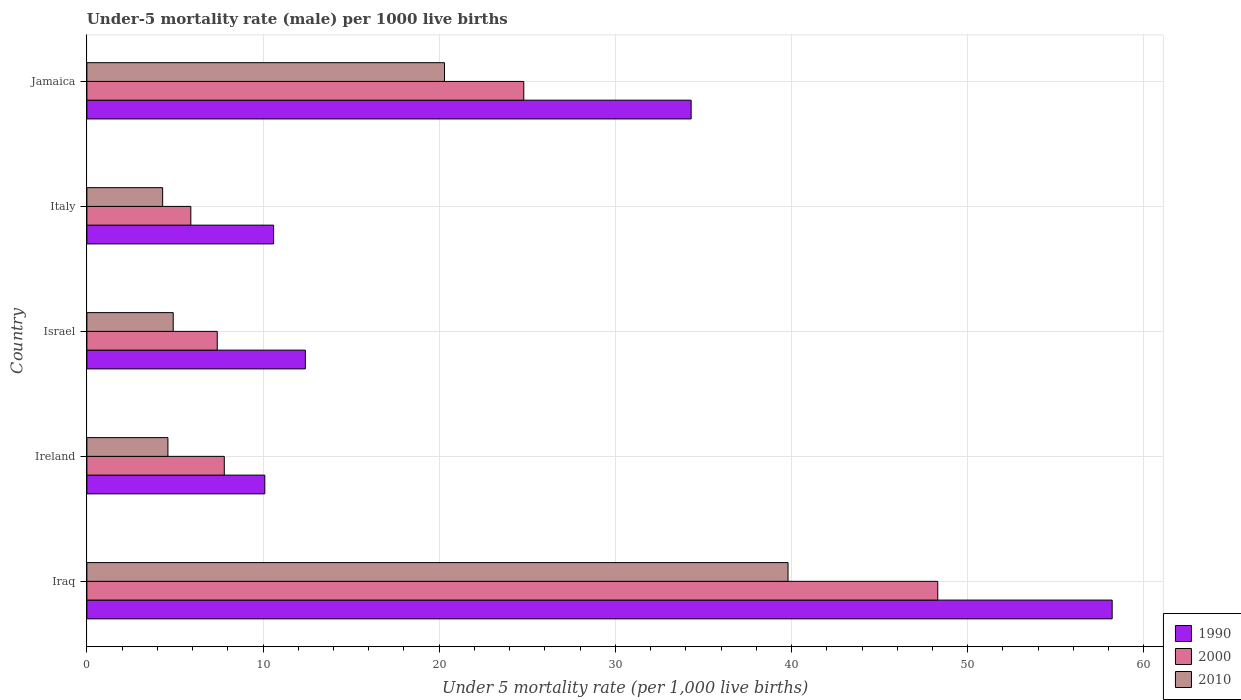How many groups of bars are there?
Offer a very short reply. 5. Are the number of bars on each tick of the Y-axis equal?
Provide a short and direct response. Yes. In how many cases, is the number of bars for a given country not equal to the number of legend labels?
Your answer should be very brief. 0. What is the under-five mortality rate in 1990 in Iraq?
Your answer should be very brief. 58.2. Across all countries, what is the maximum under-five mortality rate in 1990?
Provide a succinct answer. 58.2. Across all countries, what is the minimum under-five mortality rate in 2010?
Make the answer very short. 4.3. In which country was the under-five mortality rate in 2010 maximum?
Provide a succinct answer. Iraq. In which country was the under-five mortality rate in 1990 minimum?
Make the answer very short. Ireland. What is the total under-five mortality rate in 2000 in the graph?
Provide a succinct answer. 94.2. What is the difference between the under-five mortality rate in 1990 in Ireland and that in Israel?
Provide a short and direct response. -2.3. What is the difference between the under-five mortality rate in 1990 in Italy and the under-five mortality rate in 2000 in Iraq?
Ensure brevity in your answer.  -37.7. What is the average under-five mortality rate in 2010 per country?
Offer a very short reply. 14.78. What is the ratio of the under-five mortality rate in 2000 in Iraq to that in Ireland?
Ensure brevity in your answer.  6.19. Is the under-five mortality rate in 2010 in Israel less than that in Italy?
Keep it short and to the point. No. What is the difference between the highest and the second highest under-five mortality rate in 2000?
Keep it short and to the point. 23.5. What is the difference between the highest and the lowest under-five mortality rate in 2000?
Keep it short and to the point. 42.4. What does the 1st bar from the top in Italy represents?
Your response must be concise. 2010. Is it the case that in every country, the sum of the under-five mortality rate in 1990 and under-five mortality rate in 2010 is greater than the under-five mortality rate in 2000?
Offer a very short reply. Yes. Where does the legend appear in the graph?
Keep it short and to the point. Bottom right. How many legend labels are there?
Keep it short and to the point. 3. What is the title of the graph?
Offer a terse response. Under-5 mortality rate (male) per 1000 live births. What is the label or title of the X-axis?
Provide a succinct answer. Under 5 mortality rate (per 1,0 live births). What is the Under 5 mortality rate (per 1,000 live births) in 1990 in Iraq?
Ensure brevity in your answer.  58.2. What is the Under 5 mortality rate (per 1,000 live births) of 2000 in Iraq?
Offer a very short reply. 48.3. What is the Under 5 mortality rate (per 1,000 live births) in 2010 in Iraq?
Your answer should be very brief. 39.8. What is the Under 5 mortality rate (per 1,000 live births) of 2010 in Ireland?
Offer a very short reply. 4.6. What is the Under 5 mortality rate (per 1,000 live births) in 1990 in Israel?
Provide a short and direct response. 12.4. What is the Under 5 mortality rate (per 1,000 live births) of 1990 in Jamaica?
Keep it short and to the point. 34.3. What is the Under 5 mortality rate (per 1,000 live births) of 2000 in Jamaica?
Keep it short and to the point. 24.8. What is the Under 5 mortality rate (per 1,000 live births) of 2010 in Jamaica?
Your response must be concise. 20.3. Across all countries, what is the maximum Under 5 mortality rate (per 1,000 live births) in 1990?
Your answer should be very brief. 58.2. Across all countries, what is the maximum Under 5 mortality rate (per 1,000 live births) in 2000?
Keep it short and to the point. 48.3. Across all countries, what is the maximum Under 5 mortality rate (per 1,000 live births) in 2010?
Your answer should be very brief. 39.8. What is the total Under 5 mortality rate (per 1,000 live births) of 1990 in the graph?
Your answer should be very brief. 125.6. What is the total Under 5 mortality rate (per 1,000 live births) in 2000 in the graph?
Ensure brevity in your answer.  94.2. What is the total Under 5 mortality rate (per 1,000 live births) of 2010 in the graph?
Offer a very short reply. 73.9. What is the difference between the Under 5 mortality rate (per 1,000 live births) in 1990 in Iraq and that in Ireland?
Keep it short and to the point. 48.1. What is the difference between the Under 5 mortality rate (per 1,000 live births) of 2000 in Iraq and that in Ireland?
Offer a very short reply. 40.5. What is the difference between the Under 5 mortality rate (per 1,000 live births) in 2010 in Iraq and that in Ireland?
Provide a short and direct response. 35.2. What is the difference between the Under 5 mortality rate (per 1,000 live births) in 1990 in Iraq and that in Israel?
Ensure brevity in your answer.  45.8. What is the difference between the Under 5 mortality rate (per 1,000 live births) of 2000 in Iraq and that in Israel?
Keep it short and to the point. 40.9. What is the difference between the Under 5 mortality rate (per 1,000 live births) of 2010 in Iraq and that in Israel?
Your answer should be very brief. 34.9. What is the difference between the Under 5 mortality rate (per 1,000 live births) in 1990 in Iraq and that in Italy?
Offer a terse response. 47.6. What is the difference between the Under 5 mortality rate (per 1,000 live births) in 2000 in Iraq and that in Italy?
Your answer should be compact. 42.4. What is the difference between the Under 5 mortality rate (per 1,000 live births) in 2010 in Iraq and that in Italy?
Give a very brief answer. 35.5. What is the difference between the Under 5 mortality rate (per 1,000 live births) in 1990 in Iraq and that in Jamaica?
Give a very brief answer. 23.9. What is the difference between the Under 5 mortality rate (per 1,000 live births) in 2000 in Iraq and that in Jamaica?
Give a very brief answer. 23.5. What is the difference between the Under 5 mortality rate (per 1,000 live births) of 1990 in Ireland and that in Israel?
Offer a very short reply. -2.3. What is the difference between the Under 5 mortality rate (per 1,000 live births) in 2000 in Ireland and that in Israel?
Your answer should be compact. 0.4. What is the difference between the Under 5 mortality rate (per 1,000 live births) in 2000 in Ireland and that in Italy?
Your response must be concise. 1.9. What is the difference between the Under 5 mortality rate (per 1,000 live births) of 2010 in Ireland and that in Italy?
Your response must be concise. 0.3. What is the difference between the Under 5 mortality rate (per 1,000 live births) of 1990 in Ireland and that in Jamaica?
Keep it short and to the point. -24.2. What is the difference between the Under 5 mortality rate (per 1,000 live births) of 2000 in Ireland and that in Jamaica?
Provide a succinct answer. -17. What is the difference between the Under 5 mortality rate (per 1,000 live births) of 2010 in Ireland and that in Jamaica?
Make the answer very short. -15.7. What is the difference between the Under 5 mortality rate (per 1,000 live births) of 1990 in Israel and that in Italy?
Keep it short and to the point. 1.8. What is the difference between the Under 5 mortality rate (per 1,000 live births) in 2010 in Israel and that in Italy?
Keep it short and to the point. 0.6. What is the difference between the Under 5 mortality rate (per 1,000 live births) in 1990 in Israel and that in Jamaica?
Offer a terse response. -21.9. What is the difference between the Under 5 mortality rate (per 1,000 live births) of 2000 in Israel and that in Jamaica?
Provide a short and direct response. -17.4. What is the difference between the Under 5 mortality rate (per 1,000 live births) in 2010 in Israel and that in Jamaica?
Offer a terse response. -15.4. What is the difference between the Under 5 mortality rate (per 1,000 live births) of 1990 in Italy and that in Jamaica?
Give a very brief answer. -23.7. What is the difference between the Under 5 mortality rate (per 1,000 live births) of 2000 in Italy and that in Jamaica?
Your answer should be compact. -18.9. What is the difference between the Under 5 mortality rate (per 1,000 live births) of 1990 in Iraq and the Under 5 mortality rate (per 1,000 live births) of 2000 in Ireland?
Make the answer very short. 50.4. What is the difference between the Under 5 mortality rate (per 1,000 live births) of 1990 in Iraq and the Under 5 mortality rate (per 1,000 live births) of 2010 in Ireland?
Give a very brief answer. 53.6. What is the difference between the Under 5 mortality rate (per 1,000 live births) in 2000 in Iraq and the Under 5 mortality rate (per 1,000 live births) in 2010 in Ireland?
Ensure brevity in your answer.  43.7. What is the difference between the Under 5 mortality rate (per 1,000 live births) in 1990 in Iraq and the Under 5 mortality rate (per 1,000 live births) in 2000 in Israel?
Your answer should be compact. 50.8. What is the difference between the Under 5 mortality rate (per 1,000 live births) of 1990 in Iraq and the Under 5 mortality rate (per 1,000 live births) of 2010 in Israel?
Provide a short and direct response. 53.3. What is the difference between the Under 5 mortality rate (per 1,000 live births) of 2000 in Iraq and the Under 5 mortality rate (per 1,000 live births) of 2010 in Israel?
Give a very brief answer. 43.4. What is the difference between the Under 5 mortality rate (per 1,000 live births) of 1990 in Iraq and the Under 5 mortality rate (per 1,000 live births) of 2000 in Italy?
Offer a terse response. 52.3. What is the difference between the Under 5 mortality rate (per 1,000 live births) of 1990 in Iraq and the Under 5 mortality rate (per 1,000 live births) of 2010 in Italy?
Offer a terse response. 53.9. What is the difference between the Under 5 mortality rate (per 1,000 live births) in 1990 in Iraq and the Under 5 mortality rate (per 1,000 live births) in 2000 in Jamaica?
Provide a succinct answer. 33.4. What is the difference between the Under 5 mortality rate (per 1,000 live births) of 1990 in Iraq and the Under 5 mortality rate (per 1,000 live births) of 2010 in Jamaica?
Offer a very short reply. 37.9. What is the difference between the Under 5 mortality rate (per 1,000 live births) of 1990 in Ireland and the Under 5 mortality rate (per 1,000 live births) of 2000 in Israel?
Your answer should be very brief. 2.7. What is the difference between the Under 5 mortality rate (per 1,000 live births) in 1990 in Ireland and the Under 5 mortality rate (per 1,000 live births) in 2010 in Israel?
Provide a succinct answer. 5.2. What is the difference between the Under 5 mortality rate (per 1,000 live births) of 2000 in Ireland and the Under 5 mortality rate (per 1,000 live births) of 2010 in Israel?
Keep it short and to the point. 2.9. What is the difference between the Under 5 mortality rate (per 1,000 live births) in 1990 in Ireland and the Under 5 mortality rate (per 1,000 live births) in 2010 in Italy?
Your answer should be compact. 5.8. What is the difference between the Under 5 mortality rate (per 1,000 live births) of 1990 in Ireland and the Under 5 mortality rate (per 1,000 live births) of 2000 in Jamaica?
Your answer should be compact. -14.7. What is the difference between the Under 5 mortality rate (per 1,000 live births) in 2000 in Israel and the Under 5 mortality rate (per 1,000 live births) in 2010 in Italy?
Offer a very short reply. 3.1. What is the difference between the Under 5 mortality rate (per 1,000 live births) in 1990 in Israel and the Under 5 mortality rate (per 1,000 live births) in 2000 in Jamaica?
Make the answer very short. -12.4. What is the difference between the Under 5 mortality rate (per 1,000 live births) of 2000 in Israel and the Under 5 mortality rate (per 1,000 live births) of 2010 in Jamaica?
Provide a short and direct response. -12.9. What is the difference between the Under 5 mortality rate (per 1,000 live births) of 2000 in Italy and the Under 5 mortality rate (per 1,000 live births) of 2010 in Jamaica?
Give a very brief answer. -14.4. What is the average Under 5 mortality rate (per 1,000 live births) of 1990 per country?
Provide a succinct answer. 25.12. What is the average Under 5 mortality rate (per 1,000 live births) of 2000 per country?
Offer a very short reply. 18.84. What is the average Under 5 mortality rate (per 1,000 live births) in 2010 per country?
Provide a succinct answer. 14.78. What is the difference between the Under 5 mortality rate (per 1,000 live births) in 2000 and Under 5 mortality rate (per 1,000 live births) in 2010 in Iraq?
Make the answer very short. 8.5. What is the difference between the Under 5 mortality rate (per 1,000 live births) in 1990 and Under 5 mortality rate (per 1,000 live births) in 2000 in Ireland?
Offer a very short reply. 2.3. What is the difference between the Under 5 mortality rate (per 1,000 live births) of 1990 and Under 5 mortality rate (per 1,000 live births) of 2000 in Israel?
Make the answer very short. 5. What is the difference between the Under 5 mortality rate (per 1,000 live births) of 2000 and Under 5 mortality rate (per 1,000 live births) of 2010 in Israel?
Ensure brevity in your answer.  2.5. What is the difference between the Under 5 mortality rate (per 1,000 live births) of 1990 and Under 5 mortality rate (per 1,000 live births) of 2000 in Italy?
Provide a short and direct response. 4.7. What is the difference between the Under 5 mortality rate (per 1,000 live births) of 1990 and Under 5 mortality rate (per 1,000 live births) of 2010 in Italy?
Your answer should be very brief. 6.3. What is the ratio of the Under 5 mortality rate (per 1,000 live births) of 1990 in Iraq to that in Ireland?
Your response must be concise. 5.76. What is the ratio of the Under 5 mortality rate (per 1,000 live births) of 2000 in Iraq to that in Ireland?
Offer a very short reply. 6.19. What is the ratio of the Under 5 mortality rate (per 1,000 live births) of 2010 in Iraq to that in Ireland?
Your answer should be compact. 8.65. What is the ratio of the Under 5 mortality rate (per 1,000 live births) in 1990 in Iraq to that in Israel?
Keep it short and to the point. 4.69. What is the ratio of the Under 5 mortality rate (per 1,000 live births) of 2000 in Iraq to that in Israel?
Your answer should be very brief. 6.53. What is the ratio of the Under 5 mortality rate (per 1,000 live births) of 2010 in Iraq to that in Israel?
Your answer should be very brief. 8.12. What is the ratio of the Under 5 mortality rate (per 1,000 live births) in 1990 in Iraq to that in Italy?
Offer a very short reply. 5.49. What is the ratio of the Under 5 mortality rate (per 1,000 live births) in 2000 in Iraq to that in Italy?
Offer a very short reply. 8.19. What is the ratio of the Under 5 mortality rate (per 1,000 live births) in 2010 in Iraq to that in Italy?
Provide a succinct answer. 9.26. What is the ratio of the Under 5 mortality rate (per 1,000 live births) in 1990 in Iraq to that in Jamaica?
Give a very brief answer. 1.7. What is the ratio of the Under 5 mortality rate (per 1,000 live births) of 2000 in Iraq to that in Jamaica?
Ensure brevity in your answer.  1.95. What is the ratio of the Under 5 mortality rate (per 1,000 live births) in 2010 in Iraq to that in Jamaica?
Provide a succinct answer. 1.96. What is the ratio of the Under 5 mortality rate (per 1,000 live births) of 1990 in Ireland to that in Israel?
Ensure brevity in your answer.  0.81. What is the ratio of the Under 5 mortality rate (per 1,000 live births) in 2000 in Ireland to that in Israel?
Provide a succinct answer. 1.05. What is the ratio of the Under 5 mortality rate (per 1,000 live births) in 2010 in Ireland to that in Israel?
Provide a short and direct response. 0.94. What is the ratio of the Under 5 mortality rate (per 1,000 live births) in 1990 in Ireland to that in Italy?
Provide a succinct answer. 0.95. What is the ratio of the Under 5 mortality rate (per 1,000 live births) in 2000 in Ireland to that in Italy?
Ensure brevity in your answer.  1.32. What is the ratio of the Under 5 mortality rate (per 1,000 live births) of 2010 in Ireland to that in Italy?
Offer a terse response. 1.07. What is the ratio of the Under 5 mortality rate (per 1,000 live births) in 1990 in Ireland to that in Jamaica?
Your response must be concise. 0.29. What is the ratio of the Under 5 mortality rate (per 1,000 live births) of 2000 in Ireland to that in Jamaica?
Provide a short and direct response. 0.31. What is the ratio of the Under 5 mortality rate (per 1,000 live births) of 2010 in Ireland to that in Jamaica?
Provide a succinct answer. 0.23. What is the ratio of the Under 5 mortality rate (per 1,000 live births) in 1990 in Israel to that in Italy?
Make the answer very short. 1.17. What is the ratio of the Under 5 mortality rate (per 1,000 live births) of 2000 in Israel to that in Italy?
Make the answer very short. 1.25. What is the ratio of the Under 5 mortality rate (per 1,000 live births) in 2010 in Israel to that in Italy?
Your answer should be compact. 1.14. What is the ratio of the Under 5 mortality rate (per 1,000 live births) of 1990 in Israel to that in Jamaica?
Make the answer very short. 0.36. What is the ratio of the Under 5 mortality rate (per 1,000 live births) of 2000 in Israel to that in Jamaica?
Your answer should be compact. 0.3. What is the ratio of the Under 5 mortality rate (per 1,000 live births) in 2010 in Israel to that in Jamaica?
Offer a very short reply. 0.24. What is the ratio of the Under 5 mortality rate (per 1,000 live births) in 1990 in Italy to that in Jamaica?
Offer a terse response. 0.31. What is the ratio of the Under 5 mortality rate (per 1,000 live births) in 2000 in Italy to that in Jamaica?
Ensure brevity in your answer.  0.24. What is the ratio of the Under 5 mortality rate (per 1,000 live births) of 2010 in Italy to that in Jamaica?
Your answer should be very brief. 0.21. What is the difference between the highest and the second highest Under 5 mortality rate (per 1,000 live births) of 1990?
Offer a very short reply. 23.9. What is the difference between the highest and the second highest Under 5 mortality rate (per 1,000 live births) of 2000?
Give a very brief answer. 23.5. What is the difference between the highest and the lowest Under 5 mortality rate (per 1,000 live births) in 1990?
Your response must be concise. 48.1. What is the difference between the highest and the lowest Under 5 mortality rate (per 1,000 live births) of 2000?
Your response must be concise. 42.4. What is the difference between the highest and the lowest Under 5 mortality rate (per 1,000 live births) in 2010?
Your response must be concise. 35.5. 